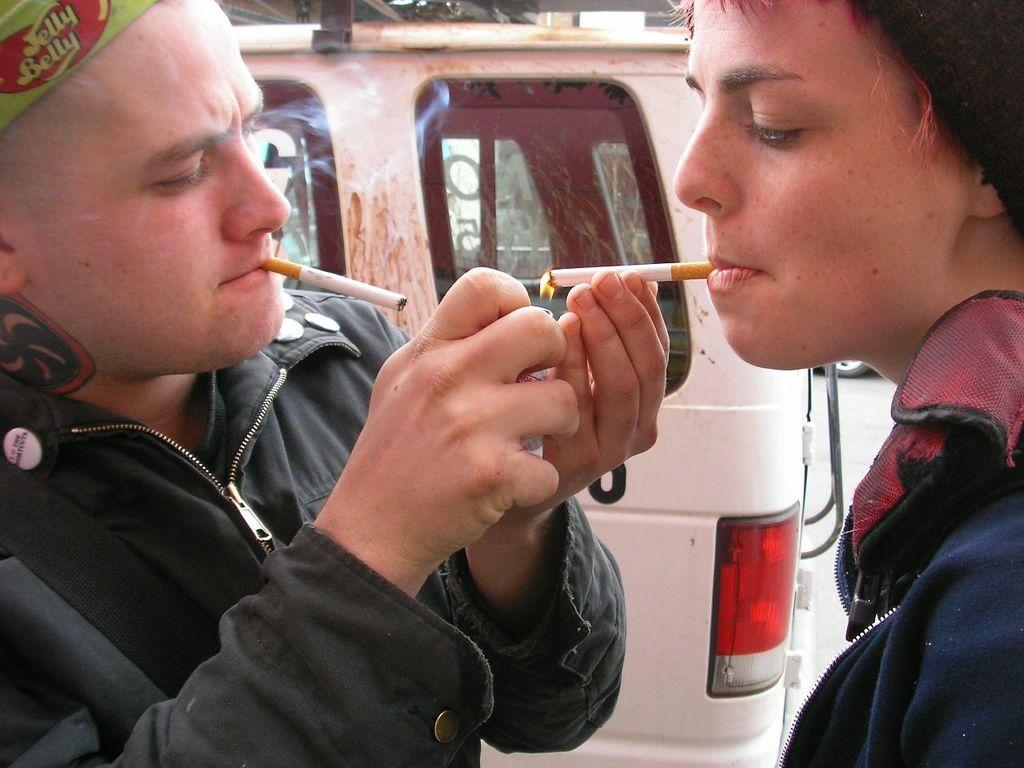How many people are in the image? There are two men in the image. What are the men holding in their hands? The men are holding cigarettes. What is one of the men doing with his cigarette? One of the men is lighting a cigarette. What can be seen in the background of the image? There is a vehicle in the background of the image. What type of star can be seen in the image? There is no star visible in the image. Does the existence of the vehicle in the background of the image imply that the men are in a specific location? The presence of the vehicle in the background of the image does not provide enough information to determine the exact location of the men. 